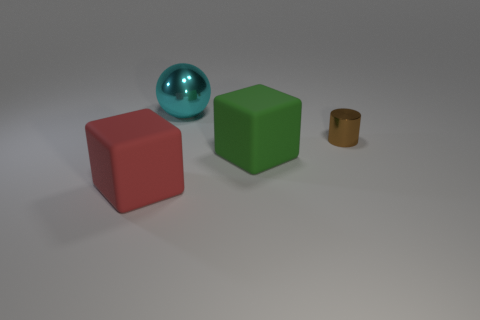Add 3 gray shiny cubes. How many objects exist? 7 Subtract all cylinders. How many objects are left? 3 Subtract 1 brown cylinders. How many objects are left? 3 Subtract all yellow balls. Subtract all yellow cylinders. How many balls are left? 1 Subtract all big red objects. Subtract all red rubber blocks. How many objects are left? 2 Add 1 big metallic balls. How many big metallic balls are left? 2 Add 4 big green blocks. How many big green blocks exist? 5 